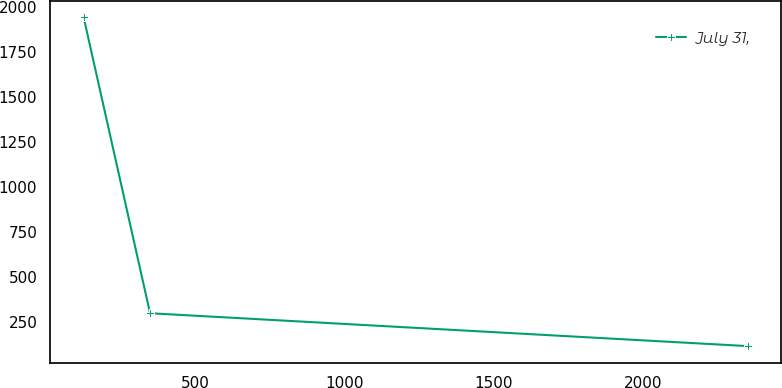Convert chart. <chart><loc_0><loc_0><loc_500><loc_500><line_chart><ecel><fcel>July 31,<nl><fcel>127.64<fcel>1942.25<nl><fcel>349.9<fcel>300.62<nl><fcel>2350.2<fcel>118.22<nl></chart> 